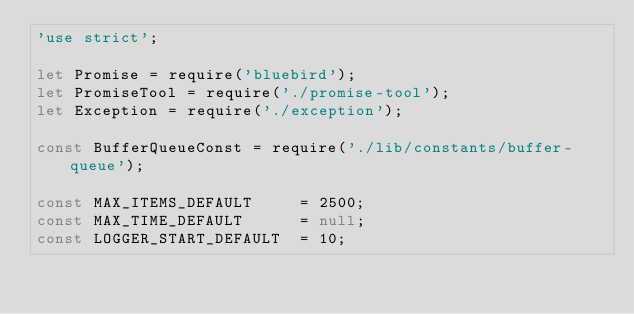<code> <loc_0><loc_0><loc_500><loc_500><_JavaScript_>'use strict';

let Promise = require('bluebird');
let PromiseTool = require('./promise-tool');
let Exception = require('./exception');

const BufferQueueConst = require('./lib/constants/buffer-queue');

const MAX_ITEMS_DEFAULT     = 2500;
const MAX_TIME_DEFAULT      = null;
const LOGGER_START_DEFAULT  = 10;</code> 